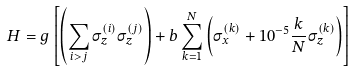<formula> <loc_0><loc_0><loc_500><loc_500>H = g \left [ \left ( \sum _ { i > j } \sigma _ { z } ^ { ( i ) } \sigma _ { z } ^ { ( j ) } \right ) + b \sum _ { k = 1 } ^ { N } \left ( \sigma _ { x } ^ { ( k ) } + 1 0 ^ { - 5 } \frac { k } { N } \sigma _ { z } ^ { ( k ) } \right ) \right ]</formula> 